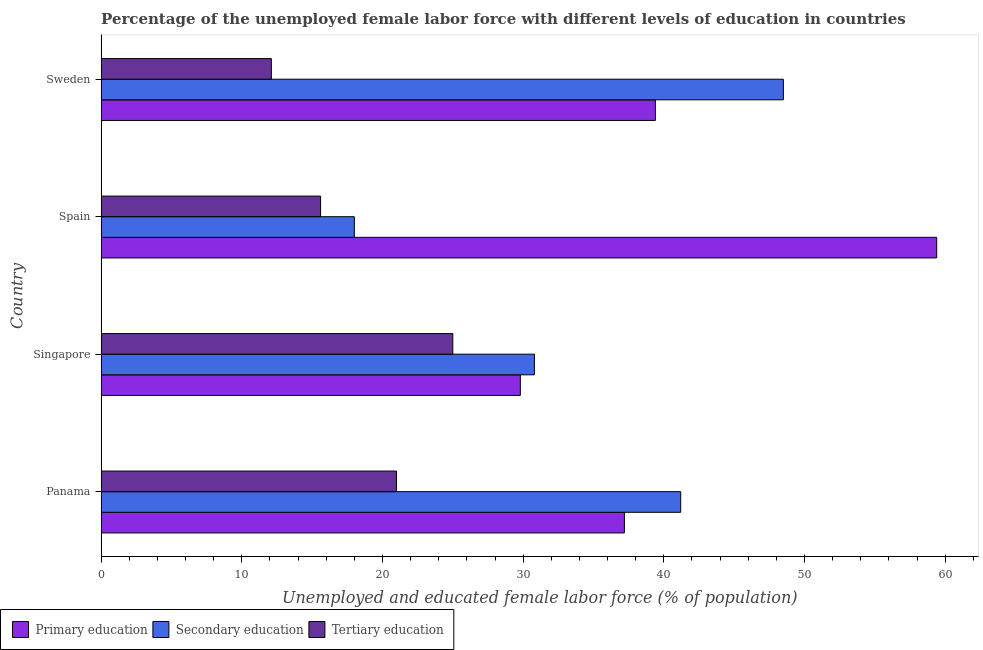How many different coloured bars are there?
Offer a terse response. 3. How many groups of bars are there?
Your response must be concise. 4. Are the number of bars per tick equal to the number of legend labels?
Keep it short and to the point. Yes. Are the number of bars on each tick of the Y-axis equal?
Ensure brevity in your answer.  Yes. How many bars are there on the 1st tick from the top?
Make the answer very short. 3. How many bars are there on the 3rd tick from the bottom?
Keep it short and to the point. 3. What is the label of the 2nd group of bars from the top?
Provide a short and direct response. Spain. What is the percentage of female labor force who received secondary education in Sweden?
Keep it short and to the point. 48.5. Across all countries, what is the maximum percentage of female labor force who received secondary education?
Keep it short and to the point. 48.5. Across all countries, what is the minimum percentage of female labor force who received secondary education?
Make the answer very short. 18. In which country was the percentage of female labor force who received tertiary education maximum?
Provide a short and direct response. Singapore. What is the total percentage of female labor force who received tertiary education in the graph?
Keep it short and to the point. 73.7. What is the difference between the percentage of female labor force who received tertiary education in Singapore and that in Spain?
Keep it short and to the point. 9.4. What is the difference between the percentage of female labor force who received primary education in Panama and the percentage of female labor force who received secondary education in Sweden?
Your answer should be very brief. -11.3. What is the average percentage of female labor force who received secondary education per country?
Keep it short and to the point. 34.62. What is the difference between the percentage of female labor force who received primary education and percentage of female labor force who received secondary education in Sweden?
Your answer should be compact. -9.1. In how many countries, is the percentage of female labor force who received primary education greater than 16 %?
Give a very brief answer. 4. What is the ratio of the percentage of female labor force who received tertiary education in Panama to that in Sweden?
Provide a short and direct response. 1.74. What is the difference between the highest and the lowest percentage of female labor force who received secondary education?
Give a very brief answer. 30.5. What does the 3rd bar from the top in Panama represents?
Your answer should be very brief. Primary education. What does the 2nd bar from the bottom in Panama represents?
Keep it short and to the point. Secondary education. Is it the case that in every country, the sum of the percentage of female labor force who received primary education and percentage of female labor force who received secondary education is greater than the percentage of female labor force who received tertiary education?
Keep it short and to the point. Yes. What is the difference between two consecutive major ticks on the X-axis?
Provide a succinct answer. 10. Does the graph contain any zero values?
Give a very brief answer. No. Where does the legend appear in the graph?
Make the answer very short. Bottom left. How are the legend labels stacked?
Your answer should be very brief. Horizontal. What is the title of the graph?
Offer a terse response. Percentage of the unemployed female labor force with different levels of education in countries. Does "Liquid fuel" appear as one of the legend labels in the graph?
Give a very brief answer. No. What is the label or title of the X-axis?
Your response must be concise. Unemployed and educated female labor force (% of population). What is the label or title of the Y-axis?
Offer a very short reply. Country. What is the Unemployed and educated female labor force (% of population) in Primary education in Panama?
Ensure brevity in your answer.  37.2. What is the Unemployed and educated female labor force (% of population) of Secondary education in Panama?
Ensure brevity in your answer.  41.2. What is the Unemployed and educated female labor force (% of population) of Primary education in Singapore?
Your answer should be very brief. 29.8. What is the Unemployed and educated female labor force (% of population) of Secondary education in Singapore?
Your response must be concise. 30.8. What is the Unemployed and educated female labor force (% of population) of Tertiary education in Singapore?
Keep it short and to the point. 25. What is the Unemployed and educated female labor force (% of population) of Primary education in Spain?
Provide a short and direct response. 59.4. What is the Unemployed and educated female labor force (% of population) of Tertiary education in Spain?
Your answer should be compact. 15.6. What is the Unemployed and educated female labor force (% of population) of Primary education in Sweden?
Your response must be concise. 39.4. What is the Unemployed and educated female labor force (% of population) in Secondary education in Sweden?
Offer a very short reply. 48.5. What is the Unemployed and educated female labor force (% of population) of Tertiary education in Sweden?
Offer a terse response. 12.1. Across all countries, what is the maximum Unemployed and educated female labor force (% of population) in Primary education?
Your answer should be very brief. 59.4. Across all countries, what is the maximum Unemployed and educated female labor force (% of population) of Secondary education?
Keep it short and to the point. 48.5. Across all countries, what is the maximum Unemployed and educated female labor force (% of population) of Tertiary education?
Your answer should be compact. 25. Across all countries, what is the minimum Unemployed and educated female labor force (% of population) of Primary education?
Offer a terse response. 29.8. Across all countries, what is the minimum Unemployed and educated female labor force (% of population) in Tertiary education?
Offer a very short reply. 12.1. What is the total Unemployed and educated female labor force (% of population) of Primary education in the graph?
Offer a very short reply. 165.8. What is the total Unemployed and educated female labor force (% of population) of Secondary education in the graph?
Make the answer very short. 138.5. What is the total Unemployed and educated female labor force (% of population) in Tertiary education in the graph?
Your response must be concise. 73.7. What is the difference between the Unemployed and educated female labor force (% of population) in Secondary education in Panama and that in Singapore?
Offer a very short reply. 10.4. What is the difference between the Unemployed and educated female labor force (% of population) of Primary education in Panama and that in Spain?
Ensure brevity in your answer.  -22.2. What is the difference between the Unemployed and educated female labor force (% of population) in Secondary education in Panama and that in Spain?
Your answer should be very brief. 23.2. What is the difference between the Unemployed and educated female labor force (% of population) in Primary education in Panama and that in Sweden?
Provide a succinct answer. -2.2. What is the difference between the Unemployed and educated female labor force (% of population) in Tertiary education in Panama and that in Sweden?
Your answer should be very brief. 8.9. What is the difference between the Unemployed and educated female labor force (% of population) in Primary education in Singapore and that in Spain?
Provide a succinct answer. -29.6. What is the difference between the Unemployed and educated female labor force (% of population) of Secondary education in Singapore and that in Spain?
Your answer should be very brief. 12.8. What is the difference between the Unemployed and educated female labor force (% of population) in Secondary education in Singapore and that in Sweden?
Make the answer very short. -17.7. What is the difference between the Unemployed and educated female labor force (% of population) in Secondary education in Spain and that in Sweden?
Provide a short and direct response. -30.5. What is the difference between the Unemployed and educated female labor force (% of population) of Primary education in Panama and the Unemployed and educated female labor force (% of population) of Secondary education in Singapore?
Offer a terse response. 6.4. What is the difference between the Unemployed and educated female labor force (% of population) in Primary education in Panama and the Unemployed and educated female labor force (% of population) in Secondary education in Spain?
Provide a short and direct response. 19.2. What is the difference between the Unemployed and educated female labor force (% of population) of Primary education in Panama and the Unemployed and educated female labor force (% of population) of Tertiary education in Spain?
Your response must be concise. 21.6. What is the difference between the Unemployed and educated female labor force (% of population) in Secondary education in Panama and the Unemployed and educated female labor force (% of population) in Tertiary education in Spain?
Provide a succinct answer. 25.6. What is the difference between the Unemployed and educated female labor force (% of population) of Primary education in Panama and the Unemployed and educated female labor force (% of population) of Tertiary education in Sweden?
Provide a succinct answer. 25.1. What is the difference between the Unemployed and educated female labor force (% of population) of Secondary education in Panama and the Unemployed and educated female labor force (% of population) of Tertiary education in Sweden?
Ensure brevity in your answer.  29.1. What is the difference between the Unemployed and educated female labor force (% of population) in Primary education in Singapore and the Unemployed and educated female labor force (% of population) in Secondary education in Spain?
Offer a terse response. 11.8. What is the difference between the Unemployed and educated female labor force (% of population) of Primary education in Singapore and the Unemployed and educated female labor force (% of population) of Tertiary education in Spain?
Give a very brief answer. 14.2. What is the difference between the Unemployed and educated female labor force (% of population) of Primary education in Singapore and the Unemployed and educated female labor force (% of population) of Secondary education in Sweden?
Provide a succinct answer. -18.7. What is the difference between the Unemployed and educated female labor force (% of population) of Primary education in Singapore and the Unemployed and educated female labor force (% of population) of Tertiary education in Sweden?
Your answer should be very brief. 17.7. What is the difference between the Unemployed and educated female labor force (% of population) of Primary education in Spain and the Unemployed and educated female labor force (% of population) of Secondary education in Sweden?
Provide a short and direct response. 10.9. What is the difference between the Unemployed and educated female labor force (% of population) of Primary education in Spain and the Unemployed and educated female labor force (% of population) of Tertiary education in Sweden?
Keep it short and to the point. 47.3. What is the average Unemployed and educated female labor force (% of population) in Primary education per country?
Keep it short and to the point. 41.45. What is the average Unemployed and educated female labor force (% of population) of Secondary education per country?
Make the answer very short. 34.62. What is the average Unemployed and educated female labor force (% of population) in Tertiary education per country?
Your answer should be compact. 18.43. What is the difference between the Unemployed and educated female labor force (% of population) in Primary education and Unemployed and educated female labor force (% of population) in Tertiary education in Panama?
Keep it short and to the point. 16.2. What is the difference between the Unemployed and educated female labor force (% of population) in Secondary education and Unemployed and educated female labor force (% of population) in Tertiary education in Panama?
Ensure brevity in your answer.  20.2. What is the difference between the Unemployed and educated female labor force (% of population) of Secondary education and Unemployed and educated female labor force (% of population) of Tertiary education in Singapore?
Your answer should be very brief. 5.8. What is the difference between the Unemployed and educated female labor force (% of population) in Primary education and Unemployed and educated female labor force (% of population) in Secondary education in Spain?
Make the answer very short. 41.4. What is the difference between the Unemployed and educated female labor force (% of population) in Primary education and Unemployed and educated female labor force (% of population) in Tertiary education in Spain?
Your answer should be very brief. 43.8. What is the difference between the Unemployed and educated female labor force (% of population) in Secondary education and Unemployed and educated female labor force (% of population) in Tertiary education in Spain?
Your answer should be very brief. 2.4. What is the difference between the Unemployed and educated female labor force (% of population) of Primary education and Unemployed and educated female labor force (% of population) of Tertiary education in Sweden?
Your answer should be compact. 27.3. What is the difference between the Unemployed and educated female labor force (% of population) of Secondary education and Unemployed and educated female labor force (% of population) of Tertiary education in Sweden?
Your response must be concise. 36.4. What is the ratio of the Unemployed and educated female labor force (% of population) of Primary education in Panama to that in Singapore?
Provide a succinct answer. 1.25. What is the ratio of the Unemployed and educated female labor force (% of population) of Secondary education in Panama to that in Singapore?
Make the answer very short. 1.34. What is the ratio of the Unemployed and educated female labor force (% of population) in Tertiary education in Panama to that in Singapore?
Make the answer very short. 0.84. What is the ratio of the Unemployed and educated female labor force (% of population) in Primary education in Panama to that in Spain?
Your response must be concise. 0.63. What is the ratio of the Unemployed and educated female labor force (% of population) of Secondary education in Panama to that in Spain?
Provide a short and direct response. 2.29. What is the ratio of the Unemployed and educated female labor force (% of population) of Tertiary education in Panama to that in Spain?
Your answer should be compact. 1.35. What is the ratio of the Unemployed and educated female labor force (% of population) in Primary education in Panama to that in Sweden?
Your response must be concise. 0.94. What is the ratio of the Unemployed and educated female labor force (% of population) in Secondary education in Panama to that in Sweden?
Give a very brief answer. 0.85. What is the ratio of the Unemployed and educated female labor force (% of population) in Tertiary education in Panama to that in Sweden?
Provide a succinct answer. 1.74. What is the ratio of the Unemployed and educated female labor force (% of population) in Primary education in Singapore to that in Spain?
Provide a succinct answer. 0.5. What is the ratio of the Unemployed and educated female labor force (% of population) in Secondary education in Singapore to that in Spain?
Keep it short and to the point. 1.71. What is the ratio of the Unemployed and educated female labor force (% of population) of Tertiary education in Singapore to that in Spain?
Offer a terse response. 1.6. What is the ratio of the Unemployed and educated female labor force (% of population) in Primary education in Singapore to that in Sweden?
Provide a succinct answer. 0.76. What is the ratio of the Unemployed and educated female labor force (% of population) of Secondary education in Singapore to that in Sweden?
Give a very brief answer. 0.64. What is the ratio of the Unemployed and educated female labor force (% of population) of Tertiary education in Singapore to that in Sweden?
Your answer should be very brief. 2.07. What is the ratio of the Unemployed and educated female labor force (% of population) in Primary education in Spain to that in Sweden?
Provide a short and direct response. 1.51. What is the ratio of the Unemployed and educated female labor force (% of population) in Secondary education in Spain to that in Sweden?
Ensure brevity in your answer.  0.37. What is the ratio of the Unemployed and educated female labor force (% of population) in Tertiary education in Spain to that in Sweden?
Offer a very short reply. 1.29. What is the difference between the highest and the second highest Unemployed and educated female labor force (% of population) in Primary education?
Offer a terse response. 20. What is the difference between the highest and the second highest Unemployed and educated female labor force (% of population) of Secondary education?
Offer a very short reply. 7.3. What is the difference between the highest and the lowest Unemployed and educated female labor force (% of population) in Primary education?
Your answer should be very brief. 29.6. What is the difference between the highest and the lowest Unemployed and educated female labor force (% of population) in Secondary education?
Provide a succinct answer. 30.5. What is the difference between the highest and the lowest Unemployed and educated female labor force (% of population) in Tertiary education?
Provide a short and direct response. 12.9. 